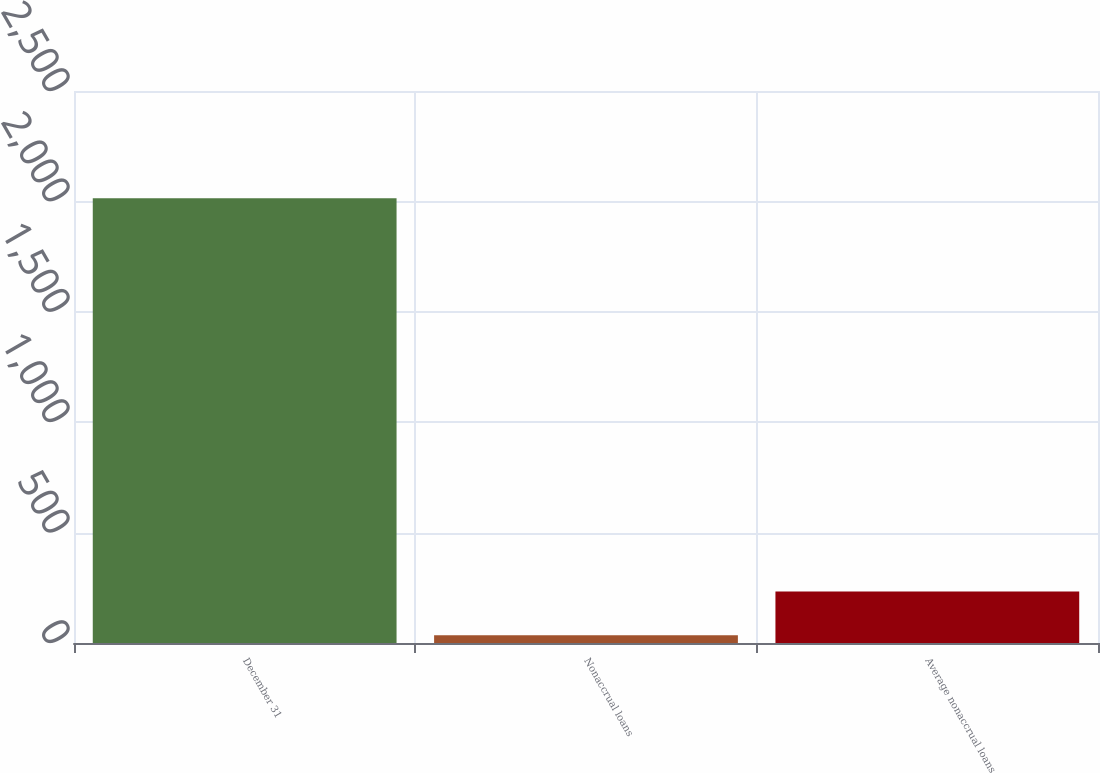Convert chart to OTSL. <chart><loc_0><loc_0><loc_500><loc_500><bar_chart><fcel>December 31<fcel>Nonaccrual loans<fcel>Average nonaccrual loans<nl><fcel>2014<fcel>35<fcel>232.9<nl></chart> 